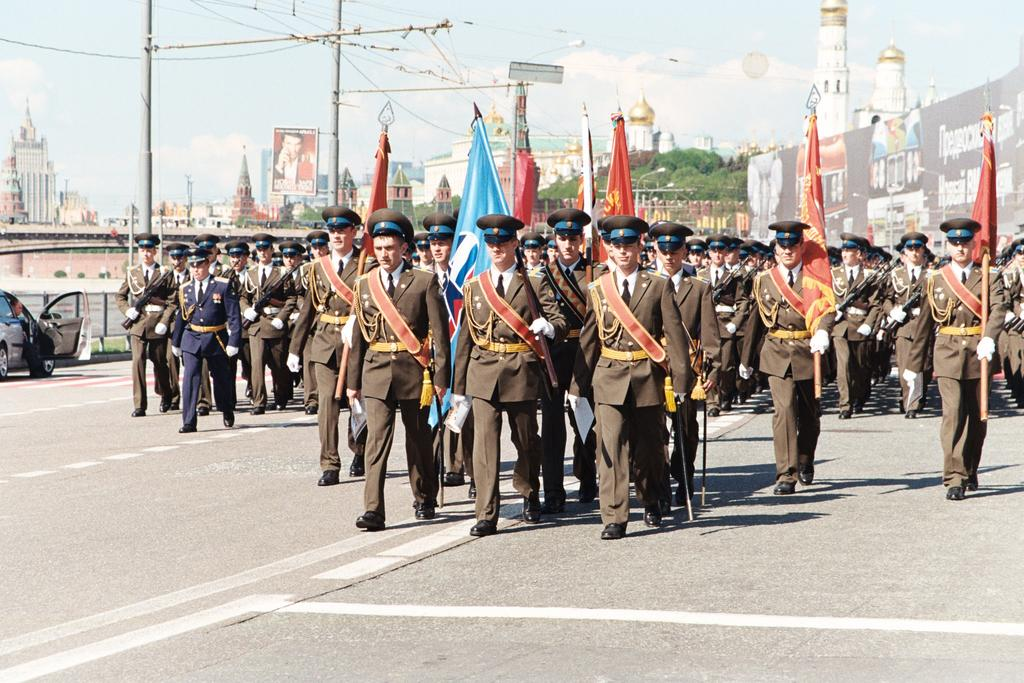What is the main subject of the image? The main subject of the image is many soldiers. What are the soldiers doing in the image? The soldiers are marching on the road and holding flags. What can be seen in the background of the image? There are buildings, trees, and the sky visible in the background of the image. What is the condition of the sky in the image? The sky is visible in the image, and clouds are present. What type of jelly can be seen on the soldiers' uniforms in the image? There is no jelly present on the soldiers' uniforms in the image. Can you hear the farmer whistling in the background of the image? There is no farmer or whistling present in the image; it features soldiers marching and holding flags. 